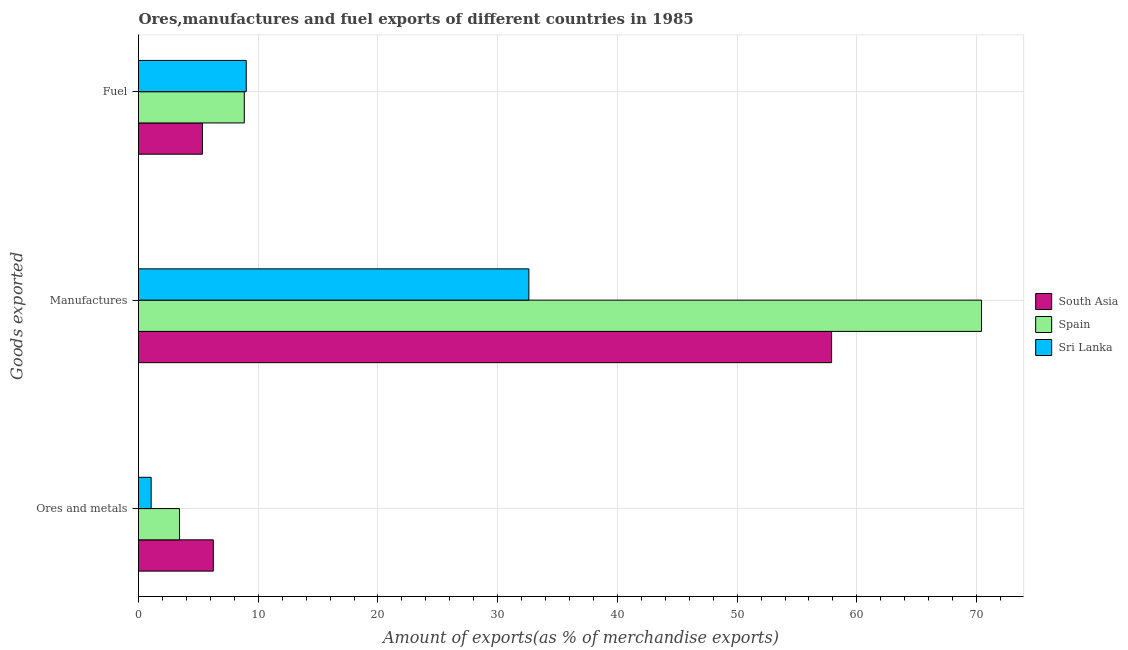How many different coloured bars are there?
Offer a very short reply. 3. How many groups of bars are there?
Offer a very short reply. 3. Are the number of bars per tick equal to the number of legend labels?
Make the answer very short. Yes. What is the label of the 2nd group of bars from the top?
Give a very brief answer. Manufactures. What is the percentage of ores and metals exports in South Asia?
Ensure brevity in your answer.  6.25. Across all countries, what is the maximum percentage of ores and metals exports?
Offer a very short reply. 6.25. Across all countries, what is the minimum percentage of manufactures exports?
Provide a short and direct response. 32.6. In which country was the percentage of ores and metals exports maximum?
Keep it short and to the point. South Asia. In which country was the percentage of manufactures exports minimum?
Offer a very short reply. Sri Lanka. What is the total percentage of fuel exports in the graph?
Give a very brief answer. 23.17. What is the difference between the percentage of ores and metals exports in South Asia and that in Sri Lanka?
Give a very brief answer. 5.19. What is the difference between the percentage of fuel exports in Sri Lanka and the percentage of manufactures exports in Spain?
Give a very brief answer. -61.41. What is the average percentage of fuel exports per country?
Your answer should be very brief. 7.72. What is the difference between the percentage of ores and metals exports and percentage of fuel exports in Sri Lanka?
Provide a short and direct response. -7.94. In how many countries, is the percentage of ores and metals exports greater than 6 %?
Make the answer very short. 1. What is the ratio of the percentage of manufactures exports in Sri Lanka to that in South Asia?
Your answer should be compact. 0.56. What is the difference between the highest and the second highest percentage of fuel exports?
Your answer should be compact. 0.16. What is the difference between the highest and the lowest percentage of manufactures exports?
Your answer should be very brief. 37.81. In how many countries, is the percentage of ores and metals exports greater than the average percentage of ores and metals exports taken over all countries?
Your response must be concise. 1. What does the 2nd bar from the bottom in Manufactures represents?
Keep it short and to the point. Spain. Is it the case that in every country, the sum of the percentage of ores and metals exports and percentage of manufactures exports is greater than the percentage of fuel exports?
Provide a short and direct response. Yes. How many bars are there?
Offer a terse response. 9. How many countries are there in the graph?
Keep it short and to the point. 3. Does the graph contain any zero values?
Provide a short and direct response. No. Does the graph contain grids?
Keep it short and to the point. Yes. What is the title of the graph?
Give a very brief answer. Ores,manufactures and fuel exports of different countries in 1985. Does "New Caledonia" appear as one of the legend labels in the graph?
Your answer should be compact. No. What is the label or title of the X-axis?
Give a very brief answer. Amount of exports(as % of merchandise exports). What is the label or title of the Y-axis?
Provide a succinct answer. Goods exported. What is the Amount of exports(as % of merchandise exports) in South Asia in Ores and metals?
Offer a terse response. 6.25. What is the Amount of exports(as % of merchandise exports) in Spain in Ores and metals?
Your response must be concise. 3.43. What is the Amount of exports(as % of merchandise exports) in Sri Lanka in Ores and metals?
Offer a terse response. 1.06. What is the Amount of exports(as % of merchandise exports) in South Asia in Manufactures?
Offer a very short reply. 57.89. What is the Amount of exports(as % of merchandise exports) of Spain in Manufactures?
Provide a short and direct response. 70.41. What is the Amount of exports(as % of merchandise exports) of Sri Lanka in Manufactures?
Your answer should be compact. 32.6. What is the Amount of exports(as % of merchandise exports) of South Asia in Fuel?
Offer a terse response. 5.34. What is the Amount of exports(as % of merchandise exports) in Spain in Fuel?
Provide a succinct answer. 8.84. What is the Amount of exports(as % of merchandise exports) of Sri Lanka in Fuel?
Keep it short and to the point. 9. Across all Goods exported, what is the maximum Amount of exports(as % of merchandise exports) of South Asia?
Keep it short and to the point. 57.89. Across all Goods exported, what is the maximum Amount of exports(as % of merchandise exports) of Spain?
Ensure brevity in your answer.  70.41. Across all Goods exported, what is the maximum Amount of exports(as % of merchandise exports) of Sri Lanka?
Offer a very short reply. 32.6. Across all Goods exported, what is the minimum Amount of exports(as % of merchandise exports) of South Asia?
Your answer should be very brief. 5.34. Across all Goods exported, what is the minimum Amount of exports(as % of merchandise exports) in Spain?
Offer a very short reply. 3.43. Across all Goods exported, what is the minimum Amount of exports(as % of merchandise exports) in Sri Lanka?
Offer a very short reply. 1.06. What is the total Amount of exports(as % of merchandise exports) of South Asia in the graph?
Ensure brevity in your answer.  69.47. What is the total Amount of exports(as % of merchandise exports) of Spain in the graph?
Provide a short and direct response. 82.67. What is the total Amount of exports(as % of merchandise exports) in Sri Lanka in the graph?
Offer a very short reply. 42.66. What is the difference between the Amount of exports(as % of merchandise exports) in South Asia in Ores and metals and that in Manufactures?
Give a very brief answer. -51.64. What is the difference between the Amount of exports(as % of merchandise exports) in Spain in Ores and metals and that in Manufactures?
Provide a short and direct response. -66.98. What is the difference between the Amount of exports(as % of merchandise exports) in Sri Lanka in Ores and metals and that in Manufactures?
Your response must be concise. -31.55. What is the difference between the Amount of exports(as % of merchandise exports) of South Asia in Ores and metals and that in Fuel?
Ensure brevity in your answer.  0.91. What is the difference between the Amount of exports(as % of merchandise exports) in Spain in Ores and metals and that in Fuel?
Keep it short and to the point. -5.41. What is the difference between the Amount of exports(as % of merchandise exports) of Sri Lanka in Ores and metals and that in Fuel?
Provide a succinct answer. -7.94. What is the difference between the Amount of exports(as % of merchandise exports) in South Asia in Manufactures and that in Fuel?
Your answer should be very brief. 52.55. What is the difference between the Amount of exports(as % of merchandise exports) in Spain in Manufactures and that in Fuel?
Your answer should be compact. 61.57. What is the difference between the Amount of exports(as % of merchandise exports) in Sri Lanka in Manufactures and that in Fuel?
Give a very brief answer. 23.61. What is the difference between the Amount of exports(as % of merchandise exports) in South Asia in Ores and metals and the Amount of exports(as % of merchandise exports) in Spain in Manufactures?
Make the answer very short. -64.16. What is the difference between the Amount of exports(as % of merchandise exports) in South Asia in Ores and metals and the Amount of exports(as % of merchandise exports) in Sri Lanka in Manufactures?
Offer a terse response. -26.35. What is the difference between the Amount of exports(as % of merchandise exports) in Spain in Ores and metals and the Amount of exports(as % of merchandise exports) in Sri Lanka in Manufactures?
Your response must be concise. -29.18. What is the difference between the Amount of exports(as % of merchandise exports) of South Asia in Ores and metals and the Amount of exports(as % of merchandise exports) of Spain in Fuel?
Offer a very short reply. -2.59. What is the difference between the Amount of exports(as % of merchandise exports) of South Asia in Ores and metals and the Amount of exports(as % of merchandise exports) of Sri Lanka in Fuel?
Offer a very short reply. -2.75. What is the difference between the Amount of exports(as % of merchandise exports) of Spain in Ores and metals and the Amount of exports(as % of merchandise exports) of Sri Lanka in Fuel?
Provide a succinct answer. -5.57. What is the difference between the Amount of exports(as % of merchandise exports) of South Asia in Manufactures and the Amount of exports(as % of merchandise exports) of Spain in Fuel?
Give a very brief answer. 49.05. What is the difference between the Amount of exports(as % of merchandise exports) in South Asia in Manufactures and the Amount of exports(as % of merchandise exports) in Sri Lanka in Fuel?
Provide a succinct answer. 48.89. What is the difference between the Amount of exports(as % of merchandise exports) of Spain in Manufactures and the Amount of exports(as % of merchandise exports) of Sri Lanka in Fuel?
Provide a succinct answer. 61.41. What is the average Amount of exports(as % of merchandise exports) in South Asia per Goods exported?
Ensure brevity in your answer.  23.16. What is the average Amount of exports(as % of merchandise exports) in Spain per Goods exported?
Give a very brief answer. 27.56. What is the average Amount of exports(as % of merchandise exports) in Sri Lanka per Goods exported?
Provide a short and direct response. 14.22. What is the difference between the Amount of exports(as % of merchandise exports) in South Asia and Amount of exports(as % of merchandise exports) in Spain in Ores and metals?
Your answer should be very brief. 2.82. What is the difference between the Amount of exports(as % of merchandise exports) of South Asia and Amount of exports(as % of merchandise exports) of Sri Lanka in Ores and metals?
Your response must be concise. 5.19. What is the difference between the Amount of exports(as % of merchandise exports) of Spain and Amount of exports(as % of merchandise exports) of Sri Lanka in Ores and metals?
Provide a succinct answer. 2.37. What is the difference between the Amount of exports(as % of merchandise exports) of South Asia and Amount of exports(as % of merchandise exports) of Spain in Manufactures?
Ensure brevity in your answer.  -12.52. What is the difference between the Amount of exports(as % of merchandise exports) in South Asia and Amount of exports(as % of merchandise exports) in Sri Lanka in Manufactures?
Your answer should be compact. 25.29. What is the difference between the Amount of exports(as % of merchandise exports) in Spain and Amount of exports(as % of merchandise exports) in Sri Lanka in Manufactures?
Your response must be concise. 37.81. What is the difference between the Amount of exports(as % of merchandise exports) in South Asia and Amount of exports(as % of merchandise exports) in Spain in Fuel?
Ensure brevity in your answer.  -3.5. What is the difference between the Amount of exports(as % of merchandise exports) of South Asia and Amount of exports(as % of merchandise exports) of Sri Lanka in Fuel?
Your response must be concise. -3.66. What is the difference between the Amount of exports(as % of merchandise exports) in Spain and Amount of exports(as % of merchandise exports) in Sri Lanka in Fuel?
Provide a succinct answer. -0.16. What is the ratio of the Amount of exports(as % of merchandise exports) in South Asia in Ores and metals to that in Manufactures?
Provide a succinct answer. 0.11. What is the ratio of the Amount of exports(as % of merchandise exports) of Spain in Ores and metals to that in Manufactures?
Your answer should be very brief. 0.05. What is the ratio of the Amount of exports(as % of merchandise exports) of Sri Lanka in Ores and metals to that in Manufactures?
Offer a very short reply. 0.03. What is the ratio of the Amount of exports(as % of merchandise exports) in South Asia in Ores and metals to that in Fuel?
Ensure brevity in your answer.  1.17. What is the ratio of the Amount of exports(as % of merchandise exports) of Spain in Ores and metals to that in Fuel?
Provide a succinct answer. 0.39. What is the ratio of the Amount of exports(as % of merchandise exports) of Sri Lanka in Ores and metals to that in Fuel?
Give a very brief answer. 0.12. What is the ratio of the Amount of exports(as % of merchandise exports) of South Asia in Manufactures to that in Fuel?
Make the answer very short. 10.85. What is the ratio of the Amount of exports(as % of merchandise exports) of Spain in Manufactures to that in Fuel?
Offer a very short reply. 7.97. What is the ratio of the Amount of exports(as % of merchandise exports) of Sri Lanka in Manufactures to that in Fuel?
Ensure brevity in your answer.  3.62. What is the difference between the highest and the second highest Amount of exports(as % of merchandise exports) in South Asia?
Provide a short and direct response. 51.64. What is the difference between the highest and the second highest Amount of exports(as % of merchandise exports) of Spain?
Keep it short and to the point. 61.57. What is the difference between the highest and the second highest Amount of exports(as % of merchandise exports) of Sri Lanka?
Provide a succinct answer. 23.61. What is the difference between the highest and the lowest Amount of exports(as % of merchandise exports) in South Asia?
Provide a succinct answer. 52.55. What is the difference between the highest and the lowest Amount of exports(as % of merchandise exports) in Spain?
Offer a very short reply. 66.98. What is the difference between the highest and the lowest Amount of exports(as % of merchandise exports) of Sri Lanka?
Your answer should be compact. 31.55. 